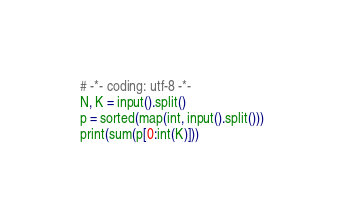Convert code to text. <code><loc_0><loc_0><loc_500><loc_500><_Python_># -*- coding: utf-8 -*-
N, K = input().split()
p = sorted(map(int, input().split()))
print(sum(p[0:int(K)]))</code> 